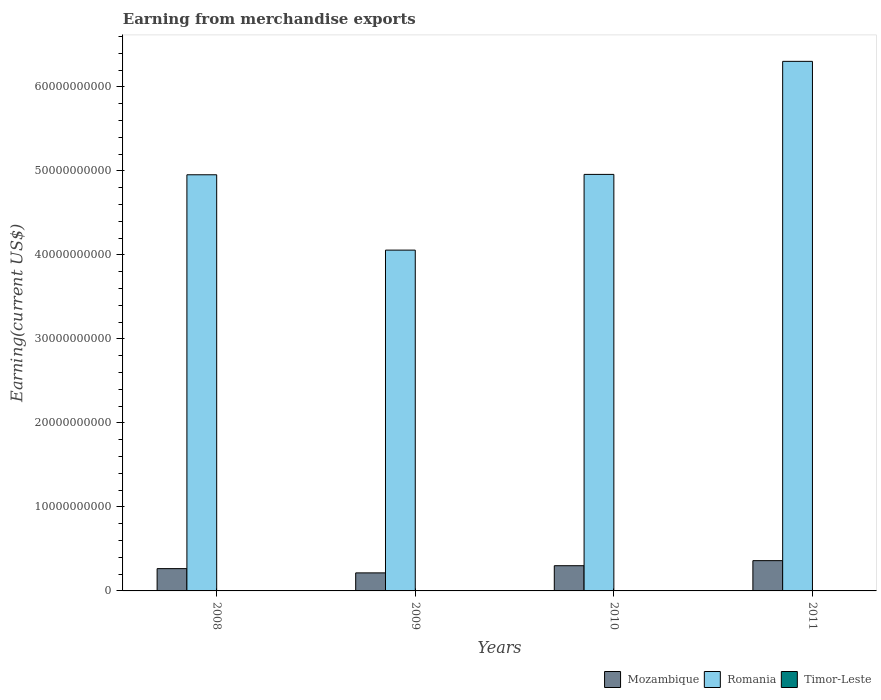Are the number of bars per tick equal to the number of legend labels?
Your answer should be very brief. Yes. How many bars are there on the 3rd tick from the left?
Give a very brief answer. 3. How many bars are there on the 3rd tick from the right?
Offer a very short reply. 3. What is the amount earned from merchandise exports in Timor-Leste in 2011?
Offer a very short reply. 1.32e+07. Across all years, what is the maximum amount earned from merchandise exports in Mozambique?
Give a very brief answer. 3.60e+09. Across all years, what is the minimum amount earned from merchandise exports in Mozambique?
Keep it short and to the point. 2.15e+09. In which year was the amount earned from merchandise exports in Mozambique maximum?
Ensure brevity in your answer.  2011. What is the total amount earned from merchandise exports in Romania in the graph?
Offer a very short reply. 2.03e+11. What is the difference between the amount earned from merchandise exports in Timor-Leste in 2010 and that in 2011?
Ensure brevity in your answer.  3.19e+06. What is the difference between the amount earned from merchandise exports in Timor-Leste in 2008 and the amount earned from merchandise exports in Mozambique in 2009?
Keep it short and to the point. -2.13e+09. What is the average amount earned from merchandise exports in Romania per year?
Your response must be concise. 5.07e+1. In the year 2008, what is the difference between the amount earned from merchandise exports in Romania and amount earned from merchandise exports in Timor-Leste?
Your answer should be very brief. 4.95e+1. What is the ratio of the amount earned from merchandise exports in Timor-Leste in 2008 to that in 2009?
Offer a terse response. 1.53. Is the amount earned from merchandise exports in Timor-Leste in 2008 less than that in 2010?
Your answer should be very brief. Yes. What is the difference between the highest and the second highest amount earned from merchandise exports in Timor-Leste?
Offer a terse response. 3.19e+06. What is the difference between the highest and the lowest amount earned from merchandise exports in Timor-Leste?
Your response must be concise. 7.90e+06. Is the sum of the amount earned from merchandise exports in Romania in 2009 and 2010 greater than the maximum amount earned from merchandise exports in Mozambique across all years?
Your response must be concise. Yes. What does the 2nd bar from the left in 2009 represents?
Provide a succinct answer. Romania. What does the 2nd bar from the right in 2009 represents?
Offer a terse response. Romania. Is it the case that in every year, the sum of the amount earned from merchandise exports in Mozambique and amount earned from merchandise exports in Romania is greater than the amount earned from merchandise exports in Timor-Leste?
Offer a terse response. Yes. How many years are there in the graph?
Give a very brief answer. 4. What is the difference between two consecutive major ticks on the Y-axis?
Offer a very short reply. 1.00e+1. Does the graph contain any zero values?
Make the answer very short. No. Where does the legend appear in the graph?
Provide a short and direct response. Bottom right. How many legend labels are there?
Provide a short and direct response. 3. What is the title of the graph?
Your answer should be very brief. Earning from merchandise exports. Does "Iraq" appear as one of the legend labels in the graph?
Provide a succinct answer. No. What is the label or title of the Y-axis?
Provide a short and direct response. Earning(current US$). What is the Earning(current US$) in Mozambique in 2008?
Your answer should be compact. 2.65e+09. What is the Earning(current US$) of Romania in 2008?
Your answer should be very brief. 4.95e+1. What is the Earning(current US$) in Timor-Leste in 2008?
Ensure brevity in your answer.  1.30e+07. What is the Earning(current US$) of Mozambique in 2009?
Give a very brief answer. 2.15e+09. What is the Earning(current US$) of Romania in 2009?
Offer a very short reply. 4.06e+1. What is the Earning(current US$) of Timor-Leste in 2009?
Your answer should be compact. 8.49e+06. What is the Earning(current US$) in Mozambique in 2010?
Your answer should be compact. 3.00e+09. What is the Earning(current US$) in Romania in 2010?
Your answer should be compact. 4.96e+1. What is the Earning(current US$) of Timor-Leste in 2010?
Ensure brevity in your answer.  1.64e+07. What is the Earning(current US$) in Mozambique in 2011?
Provide a short and direct response. 3.60e+09. What is the Earning(current US$) of Romania in 2011?
Your answer should be very brief. 6.30e+1. What is the Earning(current US$) in Timor-Leste in 2011?
Offer a very short reply. 1.32e+07. Across all years, what is the maximum Earning(current US$) of Mozambique?
Your answer should be very brief. 3.60e+09. Across all years, what is the maximum Earning(current US$) in Romania?
Your response must be concise. 6.30e+1. Across all years, what is the maximum Earning(current US$) in Timor-Leste?
Provide a short and direct response. 1.64e+07. Across all years, what is the minimum Earning(current US$) of Mozambique?
Offer a very short reply. 2.15e+09. Across all years, what is the minimum Earning(current US$) in Romania?
Your answer should be very brief. 4.06e+1. Across all years, what is the minimum Earning(current US$) of Timor-Leste?
Provide a short and direct response. 8.49e+06. What is the total Earning(current US$) in Mozambique in the graph?
Your answer should be compact. 1.14e+1. What is the total Earning(current US$) of Romania in the graph?
Offer a terse response. 2.03e+11. What is the total Earning(current US$) of Timor-Leste in the graph?
Offer a very short reply. 5.11e+07. What is the difference between the Earning(current US$) in Mozambique in 2008 and that in 2009?
Make the answer very short. 5.06e+08. What is the difference between the Earning(current US$) of Romania in 2008 and that in 2009?
Provide a succinct answer. 8.97e+09. What is the difference between the Earning(current US$) in Timor-Leste in 2008 and that in 2009?
Keep it short and to the point. 4.51e+06. What is the difference between the Earning(current US$) of Mozambique in 2008 and that in 2010?
Give a very brief answer. -3.47e+08. What is the difference between the Earning(current US$) of Romania in 2008 and that in 2010?
Your answer should be compact. -4.41e+07. What is the difference between the Earning(current US$) in Timor-Leste in 2008 and that in 2010?
Provide a short and direct response. -3.40e+06. What is the difference between the Earning(current US$) in Mozambique in 2008 and that in 2011?
Offer a very short reply. -9.51e+08. What is the difference between the Earning(current US$) in Romania in 2008 and that in 2011?
Your response must be concise. -1.35e+1. What is the difference between the Earning(current US$) in Timor-Leste in 2008 and that in 2011?
Provide a short and direct response. -2.03e+05. What is the difference between the Earning(current US$) of Mozambique in 2009 and that in 2010?
Keep it short and to the point. -8.53e+08. What is the difference between the Earning(current US$) of Romania in 2009 and that in 2010?
Your answer should be compact. -9.01e+09. What is the difference between the Earning(current US$) in Timor-Leste in 2009 and that in 2010?
Your response must be concise. -7.90e+06. What is the difference between the Earning(current US$) of Mozambique in 2009 and that in 2011?
Give a very brief answer. -1.46e+09. What is the difference between the Earning(current US$) in Romania in 2009 and that in 2011?
Keep it short and to the point. -2.25e+1. What is the difference between the Earning(current US$) in Timor-Leste in 2009 and that in 2011?
Ensure brevity in your answer.  -4.71e+06. What is the difference between the Earning(current US$) of Mozambique in 2010 and that in 2011?
Your answer should be very brief. -6.04e+08. What is the difference between the Earning(current US$) in Romania in 2010 and that in 2011?
Offer a very short reply. -1.35e+1. What is the difference between the Earning(current US$) of Timor-Leste in 2010 and that in 2011?
Give a very brief answer. 3.19e+06. What is the difference between the Earning(current US$) of Mozambique in 2008 and the Earning(current US$) of Romania in 2009?
Your answer should be very brief. -3.79e+1. What is the difference between the Earning(current US$) of Mozambique in 2008 and the Earning(current US$) of Timor-Leste in 2009?
Your answer should be very brief. 2.64e+09. What is the difference between the Earning(current US$) of Romania in 2008 and the Earning(current US$) of Timor-Leste in 2009?
Make the answer very short. 4.95e+1. What is the difference between the Earning(current US$) of Mozambique in 2008 and the Earning(current US$) of Romania in 2010?
Your response must be concise. -4.69e+1. What is the difference between the Earning(current US$) of Mozambique in 2008 and the Earning(current US$) of Timor-Leste in 2010?
Your answer should be very brief. 2.64e+09. What is the difference between the Earning(current US$) of Romania in 2008 and the Earning(current US$) of Timor-Leste in 2010?
Offer a very short reply. 4.95e+1. What is the difference between the Earning(current US$) of Mozambique in 2008 and the Earning(current US$) of Romania in 2011?
Your answer should be compact. -6.04e+1. What is the difference between the Earning(current US$) in Mozambique in 2008 and the Earning(current US$) in Timor-Leste in 2011?
Your answer should be very brief. 2.64e+09. What is the difference between the Earning(current US$) of Romania in 2008 and the Earning(current US$) of Timor-Leste in 2011?
Your response must be concise. 4.95e+1. What is the difference between the Earning(current US$) of Mozambique in 2009 and the Earning(current US$) of Romania in 2010?
Offer a very short reply. -4.74e+1. What is the difference between the Earning(current US$) in Mozambique in 2009 and the Earning(current US$) in Timor-Leste in 2010?
Make the answer very short. 2.13e+09. What is the difference between the Earning(current US$) in Romania in 2009 and the Earning(current US$) in Timor-Leste in 2010?
Offer a terse response. 4.06e+1. What is the difference between the Earning(current US$) in Mozambique in 2009 and the Earning(current US$) in Romania in 2011?
Give a very brief answer. -6.09e+1. What is the difference between the Earning(current US$) of Mozambique in 2009 and the Earning(current US$) of Timor-Leste in 2011?
Ensure brevity in your answer.  2.13e+09. What is the difference between the Earning(current US$) of Romania in 2009 and the Earning(current US$) of Timor-Leste in 2011?
Ensure brevity in your answer.  4.06e+1. What is the difference between the Earning(current US$) of Mozambique in 2010 and the Earning(current US$) of Romania in 2011?
Make the answer very short. -6.00e+1. What is the difference between the Earning(current US$) in Mozambique in 2010 and the Earning(current US$) in Timor-Leste in 2011?
Keep it short and to the point. 2.99e+09. What is the difference between the Earning(current US$) in Romania in 2010 and the Earning(current US$) in Timor-Leste in 2011?
Provide a succinct answer. 4.96e+1. What is the average Earning(current US$) of Mozambique per year?
Give a very brief answer. 2.85e+09. What is the average Earning(current US$) of Romania per year?
Offer a terse response. 5.07e+1. What is the average Earning(current US$) of Timor-Leste per year?
Keep it short and to the point. 1.28e+07. In the year 2008, what is the difference between the Earning(current US$) in Mozambique and Earning(current US$) in Romania?
Make the answer very short. -4.69e+1. In the year 2008, what is the difference between the Earning(current US$) of Mozambique and Earning(current US$) of Timor-Leste?
Make the answer very short. 2.64e+09. In the year 2008, what is the difference between the Earning(current US$) in Romania and Earning(current US$) in Timor-Leste?
Give a very brief answer. 4.95e+1. In the year 2009, what is the difference between the Earning(current US$) in Mozambique and Earning(current US$) in Romania?
Provide a short and direct response. -3.84e+1. In the year 2009, what is the difference between the Earning(current US$) of Mozambique and Earning(current US$) of Timor-Leste?
Make the answer very short. 2.14e+09. In the year 2009, what is the difference between the Earning(current US$) in Romania and Earning(current US$) in Timor-Leste?
Ensure brevity in your answer.  4.06e+1. In the year 2010, what is the difference between the Earning(current US$) in Mozambique and Earning(current US$) in Romania?
Make the answer very short. -4.66e+1. In the year 2010, what is the difference between the Earning(current US$) in Mozambique and Earning(current US$) in Timor-Leste?
Keep it short and to the point. 2.98e+09. In the year 2010, what is the difference between the Earning(current US$) in Romania and Earning(current US$) in Timor-Leste?
Your answer should be compact. 4.96e+1. In the year 2011, what is the difference between the Earning(current US$) in Mozambique and Earning(current US$) in Romania?
Give a very brief answer. -5.94e+1. In the year 2011, what is the difference between the Earning(current US$) in Mozambique and Earning(current US$) in Timor-Leste?
Give a very brief answer. 3.59e+09. In the year 2011, what is the difference between the Earning(current US$) in Romania and Earning(current US$) in Timor-Leste?
Give a very brief answer. 6.30e+1. What is the ratio of the Earning(current US$) in Mozambique in 2008 to that in 2009?
Offer a terse response. 1.24. What is the ratio of the Earning(current US$) in Romania in 2008 to that in 2009?
Offer a very short reply. 1.22. What is the ratio of the Earning(current US$) of Timor-Leste in 2008 to that in 2009?
Make the answer very short. 1.53. What is the ratio of the Earning(current US$) of Mozambique in 2008 to that in 2010?
Your response must be concise. 0.88. What is the ratio of the Earning(current US$) in Timor-Leste in 2008 to that in 2010?
Offer a very short reply. 0.79. What is the ratio of the Earning(current US$) of Mozambique in 2008 to that in 2011?
Offer a very short reply. 0.74. What is the ratio of the Earning(current US$) in Romania in 2008 to that in 2011?
Provide a short and direct response. 0.79. What is the ratio of the Earning(current US$) of Timor-Leste in 2008 to that in 2011?
Your answer should be compact. 0.98. What is the ratio of the Earning(current US$) of Mozambique in 2009 to that in 2010?
Your response must be concise. 0.72. What is the ratio of the Earning(current US$) of Romania in 2009 to that in 2010?
Give a very brief answer. 0.82. What is the ratio of the Earning(current US$) in Timor-Leste in 2009 to that in 2010?
Give a very brief answer. 0.52. What is the ratio of the Earning(current US$) of Mozambique in 2009 to that in 2011?
Your answer should be compact. 0.6. What is the ratio of the Earning(current US$) in Romania in 2009 to that in 2011?
Offer a very short reply. 0.64. What is the ratio of the Earning(current US$) of Timor-Leste in 2009 to that in 2011?
Provide a succinct answer. 0.64. What is the ratio of the Earning(current US$) in Mozambique in 2010 to that in 2011?
Offer a terse response. 0.83. What is the ratio of the Earning(current US$) of Romania in 2010 to that in 2011?
Offer a terse response. 0.79. What is the ratio of the Earning(current US$) in Timor-Leste in 2010 to that in 2011?
Your answer should be compact. 1.24. What is the difference between the highest and the second highest Earning(current US$) in Mozambique?
Your response must be concise. 6.04e+08. What is the difference between the highest and the second highest Earning(current US$) in Romania?
Offer a very short reply. 1.35e+1. What is the difference between the highest and the second highest Earning(current US$) of Timor-Leste?
Keep it short and to the point. 3.19e+06. What is the difference between the highest and the lowest Earning(current US$) in Mozambique?
Make the answer very short. 1.46e+09. What is the difference between the highest and the lowest Earning(current US$) of Romania?
Offer a terse response. 2.25e+1. What is the difference between the highest and the lowest Earning(current US$) of Timor-Leste?
Provide a succinct answer. 7.90e+06. 